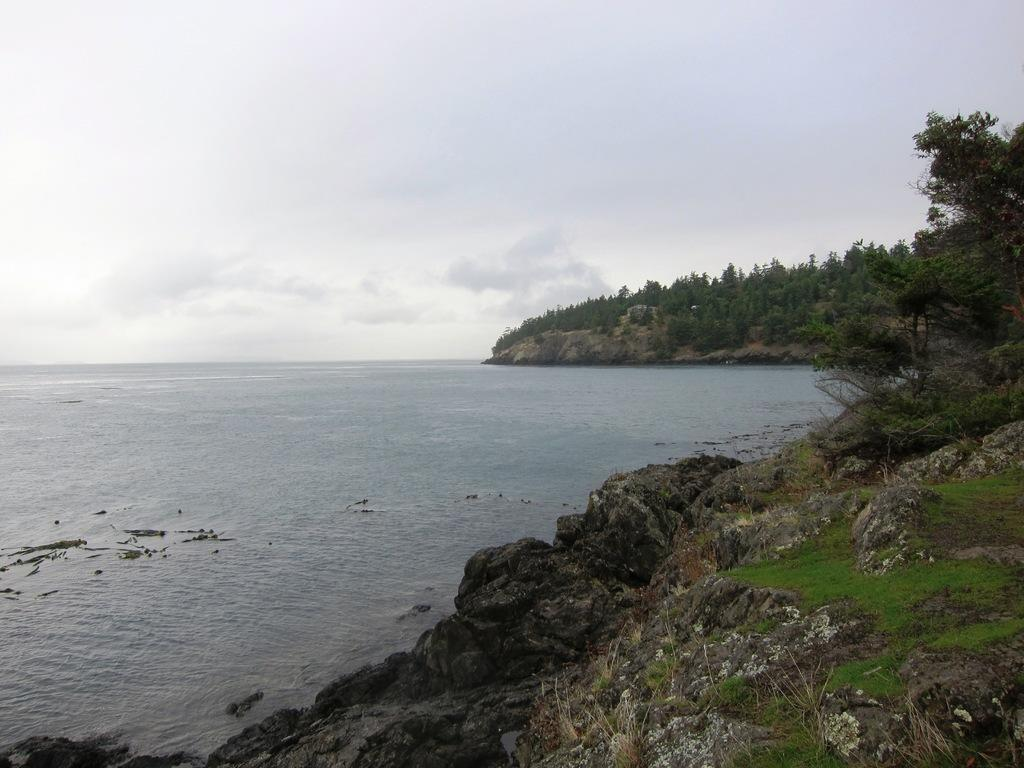What natural feature is prominently featured in the image? The image contains the sea. What type of vegetation can be seen in the image? There are many trees and plants in the image. How would you describe the sky in the image? The sky is cloudy in the image. What type of terrain is visible at the bottom of the image? There is a grassy land at the bottom of the image. What type of record can be seen on the grassy land in the image? There is no record present in the image; it features the sea, trees and plants, a cloudy sky, and grassy land. 